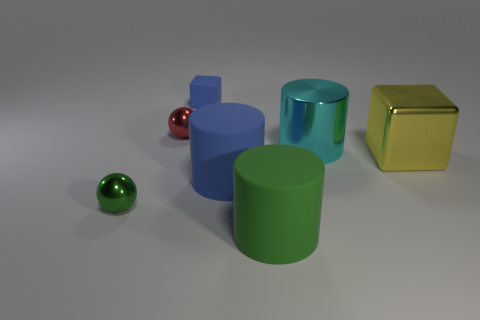Is the number of green cylinders that are in front of the cyan metal cylinder less than the number of big gray things?
Make the answer very short. No. Are there any blue blocks made of the same material as the tiny blue object?
Ensure brevity in your answer.  No. There is a red metal thing; does it have the same size as the cylinder that is behind the yellow shiny object?
Your response must be concise. No. Is there a small matte thing that has the same color as the big metal cylinder?
Provide a succinct answer. No. Is the material of the tiny green object the same as the large blue cylinder?
Your answer should be very brief. No. There is a small matte cube; how many large metallic cubes are in front of it?
Offer a very short reply. 1. There is a large object that is behind the green rubber object and in front of the big yellow cube; what is its material?
Provide a succinct answer. Rubber. What number of blue cubes have the same size as the metallic cylinder?
Offer a very short reply. 0. What color is the block right of the big rubber cylinder that is on the right side of the blue cylinder?
Make the answer very short. Yellow. Is there a yellow shiny cube?
Offer a terse response. Yes. 